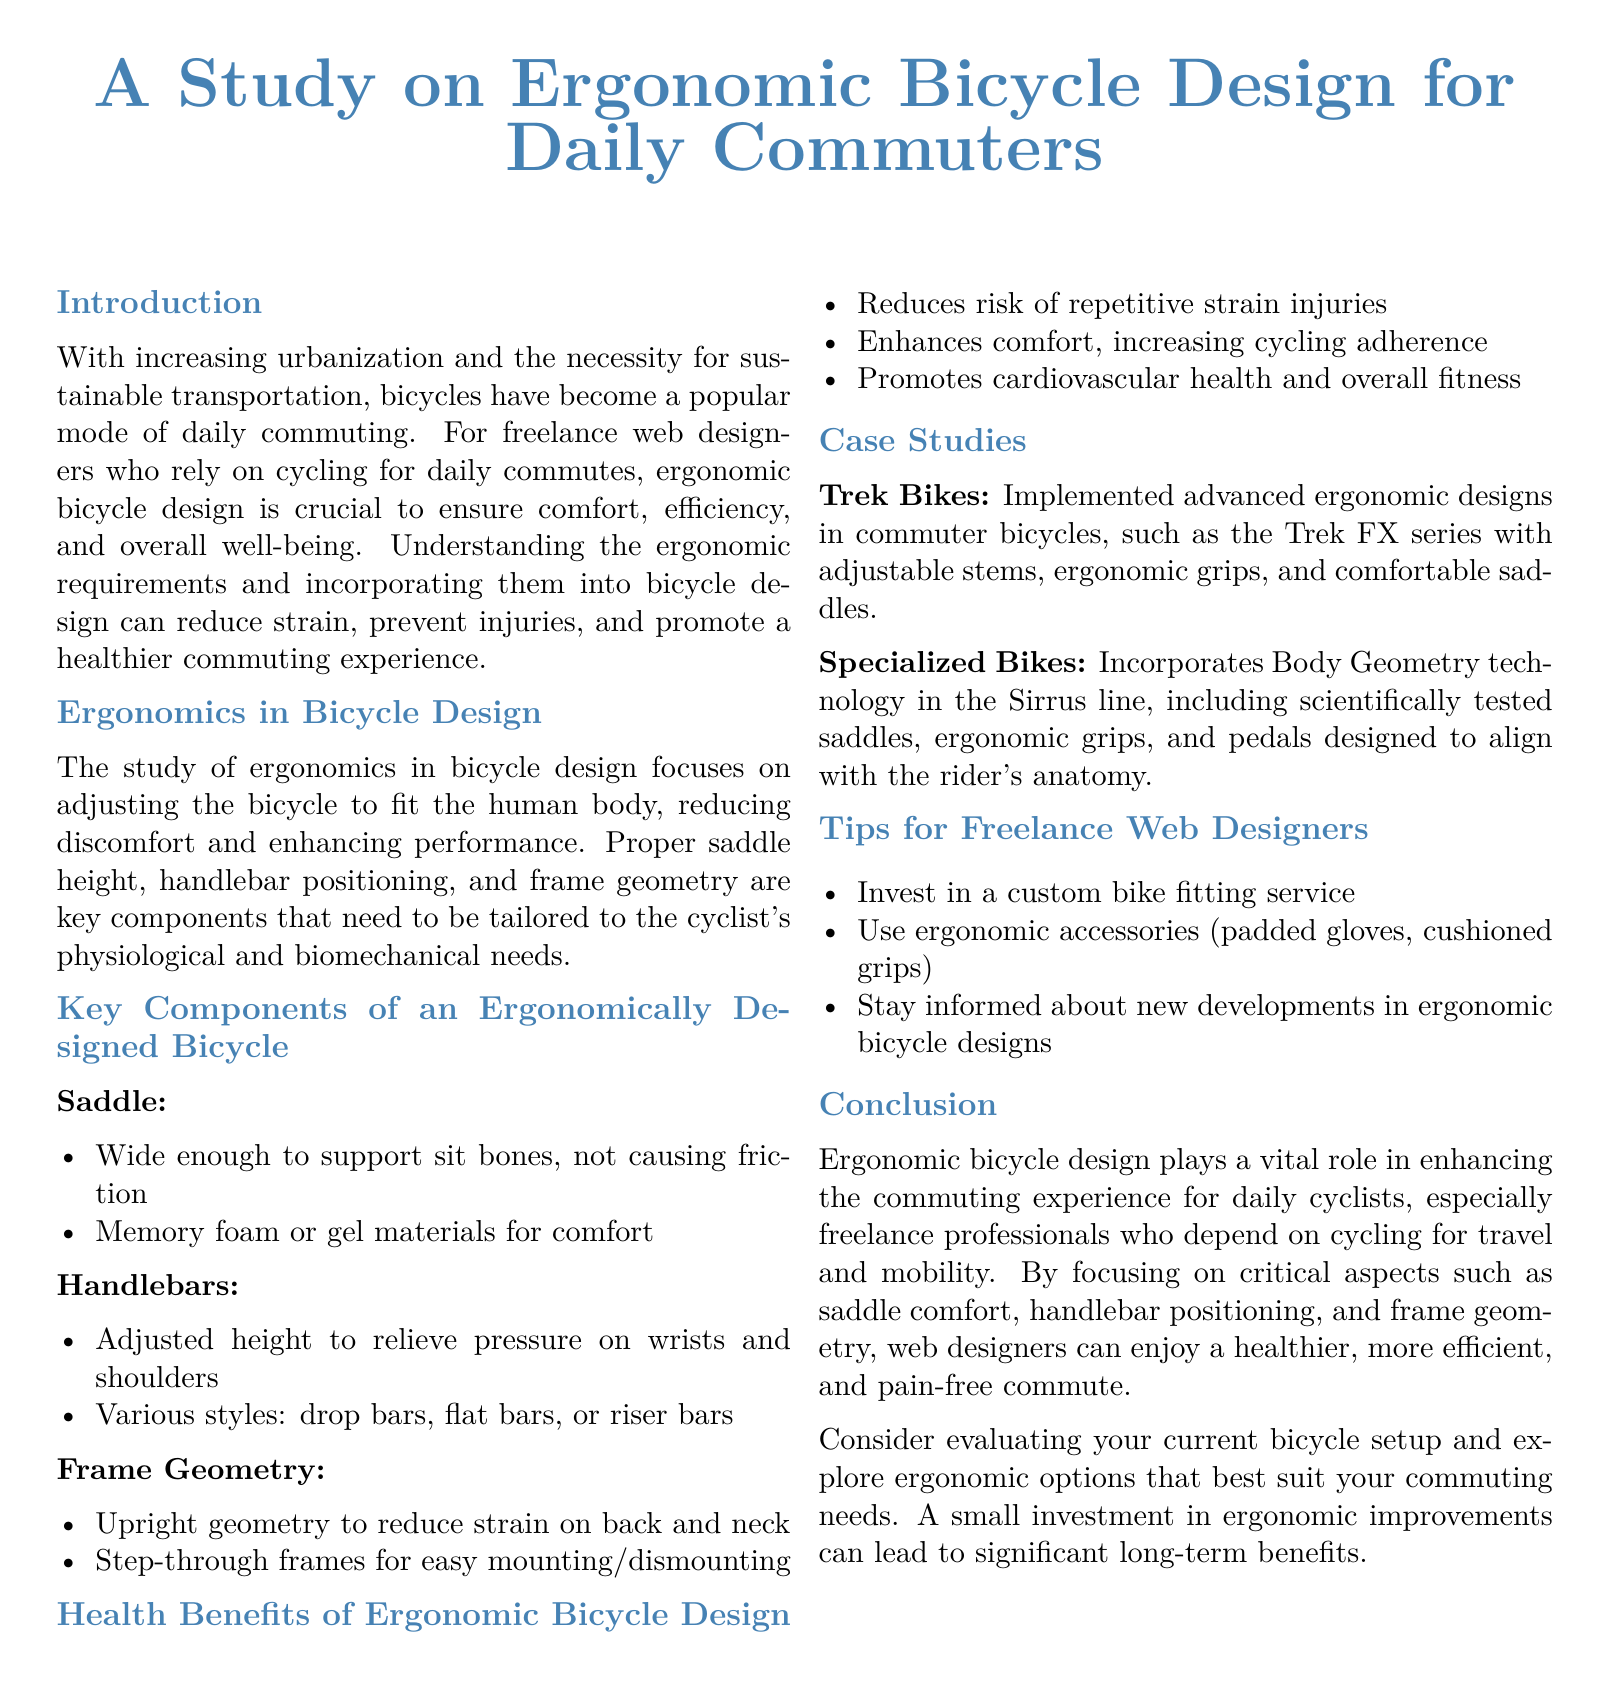What is the main focus of the study? The study focuses on designing bicycles that fit the human body to enhance comfort and performance for daily commuting.
Answer: Ergonomic bicycle design What are two key components in ergonomic bicycle design? The document lists saddle height and handlebar positioning as key components needing adjustment for ergonomics.
Answer: Saddle and handlebars What health benefit is associated with ergonomic bicycle design? The document states that ergonomic design reduces the risk of repetitive strain injuries, enhancing overall health.
Answer: Reduces risk of injuries Which bicycle brand incorporates Body Geometry technology? The document mentions Specialized Bikes as a brand incorporating this technology into their bicycle designs.
Answer: Specialized Bikes What is one tip for freelance web designers to improve cycling comfort? The document suggests investing in a custom bike fitting service for enhanced comfort while cycling.
Answer: Custom bike fitting service What type of geometry does the paper recommend for reducing strain? The paper suggests using an upright geometry in bicycle design to minimize strain.
Answer: Upright geometry What is the target audience for this study? The target audience identified is freelance web designers who use bicycles for commuting.
Answer: Freelance web designers Which series by Trek Bikes includes ergonomic designs? The document refers to the Trek FX series as implementing advanced ergonomic designs.
Answer: Trek FX series 